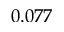<formula> <loc_0><loc_0><loc_500><loc_500>0 . 0 7 7</formula> 